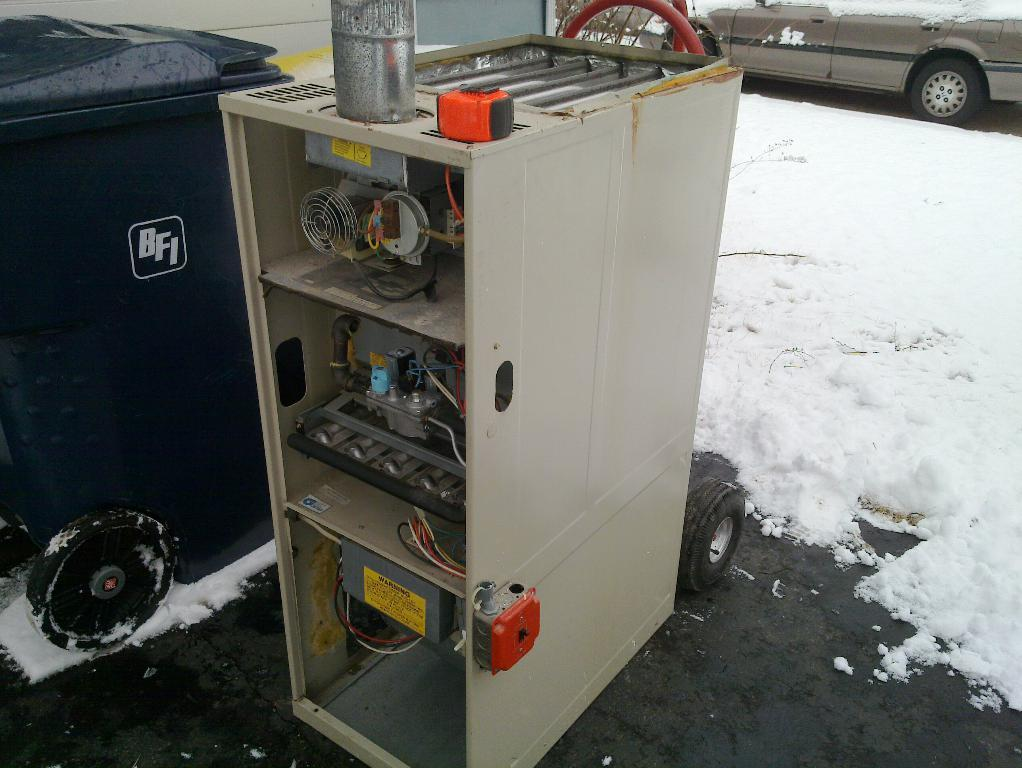What can be seen in the background of the image? There is a wall in the image. What is on the surface in the image? There are objects on the surface in the image, including a box and a machine. What is happening on the road in the image? There is a car on the road in the image. What type of weather is depicted in the image? There is snow in the image. Where is the station located in the image? There is no station present in the image. What type of band is playing in the image? There is no band present in the image. 